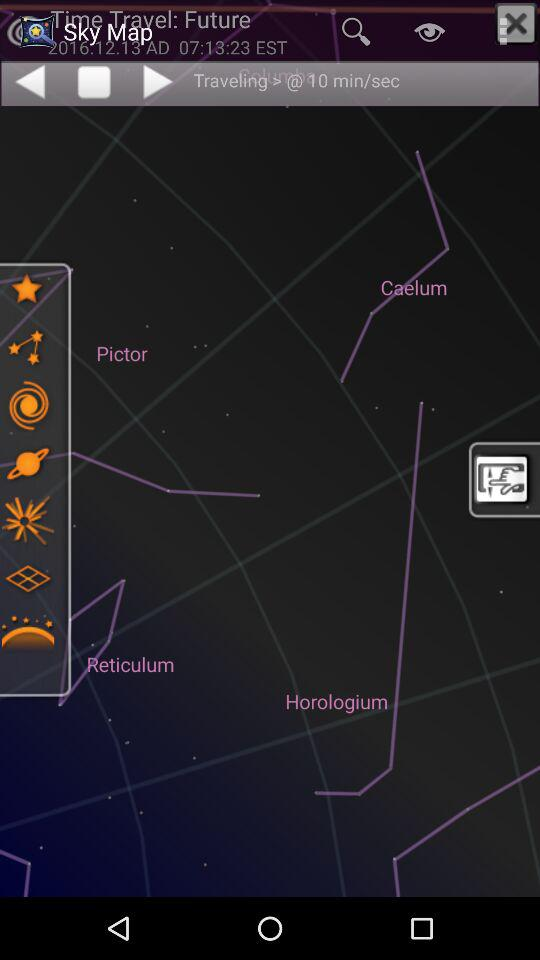What is the date? The date is December 13, 2016 AD. 